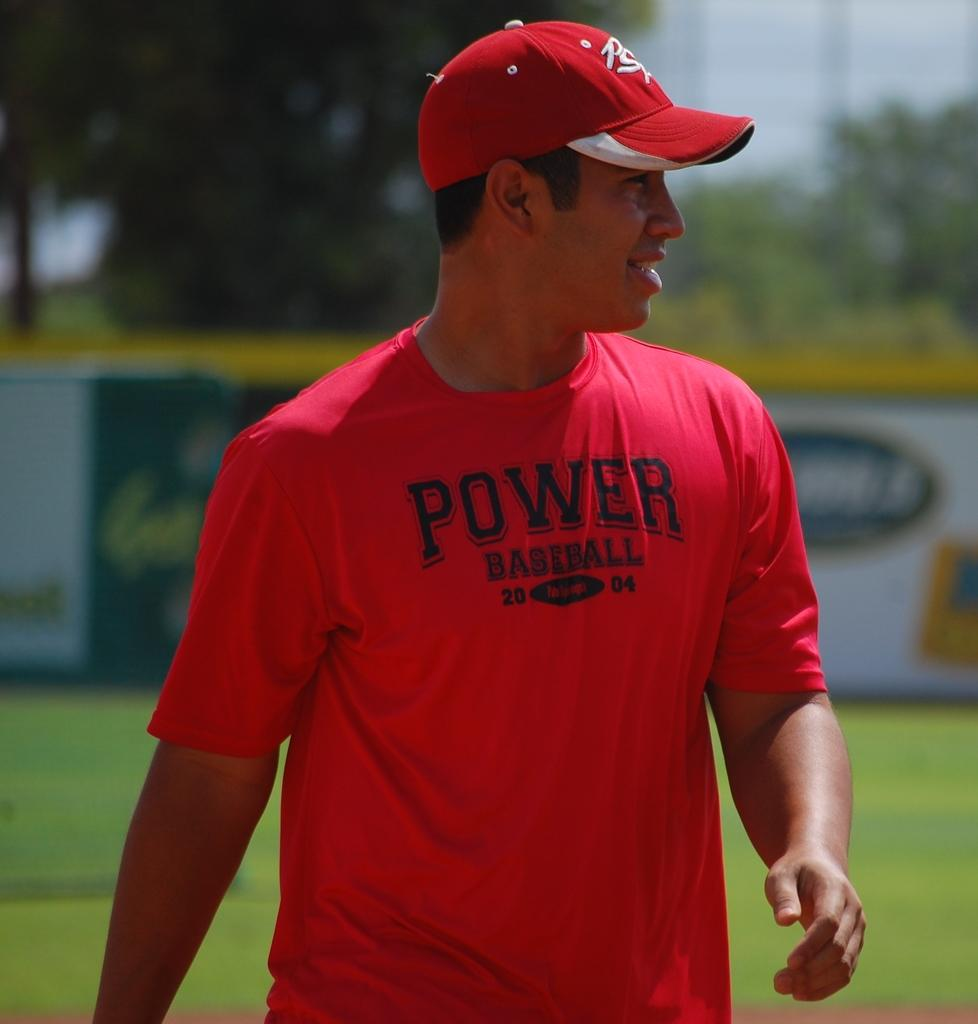<image>
Write a terse but informative summary of the picture. Man wearing a red shirt that says "Power Baseball" on it. 